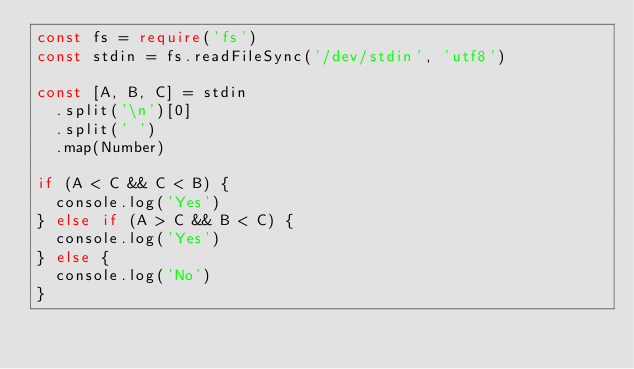<code> <loc_0><loc_0><loc_500><loc_500><_TypeScript_>const fs = require('fs')
const stdin = fs.readFileSync('/dev/stdin', 'utf8')

const [A, B, C] = stdin
  .split('\n')[0]
  .split(' ')
  .map(Number)

if (A < C && C < B) {
  console.log('Yes')
} else if (A > C && B < C) {
  console.log('Yes')
} else {
  console.log('No')
}
</code> 